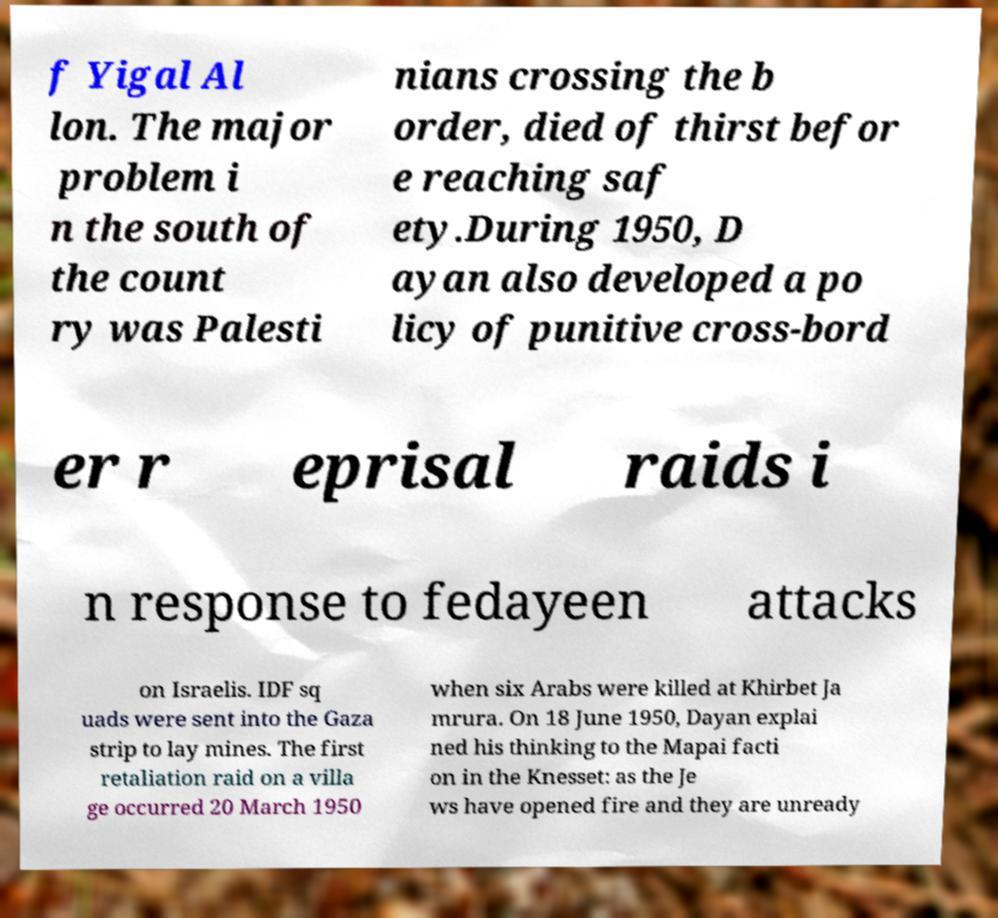I need the written content from this picture converted into text. Can you do that? f Yigal Al lon. The major problem i n the south of the count ry was Palesti nians crossing the b order, died of thirst befor e reaching saf ety.During 1950, D ayan also developed a po licy of punitive cross-bord er r eprisal raids i n response to fedayeen attacks on Israelis. IDF sq uads were sent into the Gaza strip to lay mines. The first retaliation raid on a villa ge occurred 20 March 1950 when six Arabs were killed at Khirbet Ja mrura. On 18 June 1950, Dayan explai ned his thinking to the Mapai facti on in the Knesset: as the Je ws have opened fire and they are unready 